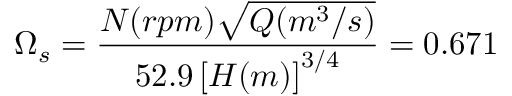<formula> <loc_0><loc_0><loc_500><loc_500>\Omega _ { s } = \frac { N ( r p m ) \sqrt { Q ( m ^ { 3 } / s ) } } { 5 2 . 9 \left [ H ( m ) \right ] ^ { 3 / 4 } } = 0 . 6 7 1</formula> 